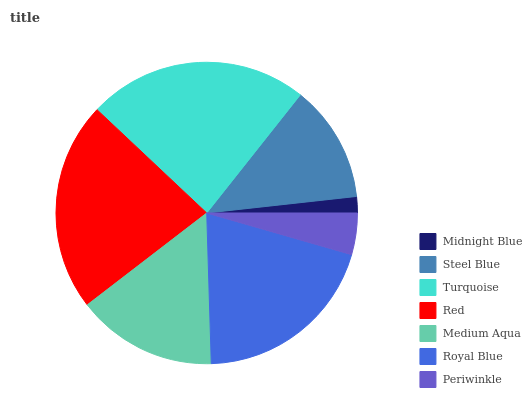Is Midnight Blue the minimum?
Answer yes or no. Yes. Is Turquoise the maximum?
Answer yes or no. Yes. Is Steel Blue the minimum?
Answer yes or no. No. Is Steel Blue the maximum?
Answer yes or no. No. Is Steel Blue greater than Midnight Blue?
Answer yes or no. Yes. Is Midnight Blue less than Steel Blue?
Answer yes or no. Yes. Is Midnight Blue greater than Steel Blue?
Answer yes or no. No. Is Steel Blue less than Midnight Blue?
Answer yes or no. No. Is Medium Aqua the high median?
Answer yes or no. Yes. Is Medium Aqua the low median?
Answer yes or no. Yes. Is Steel Blue the high median?
Answer yes or no. No. Is Royal Blue the low median?
Answer yes or no. No. 